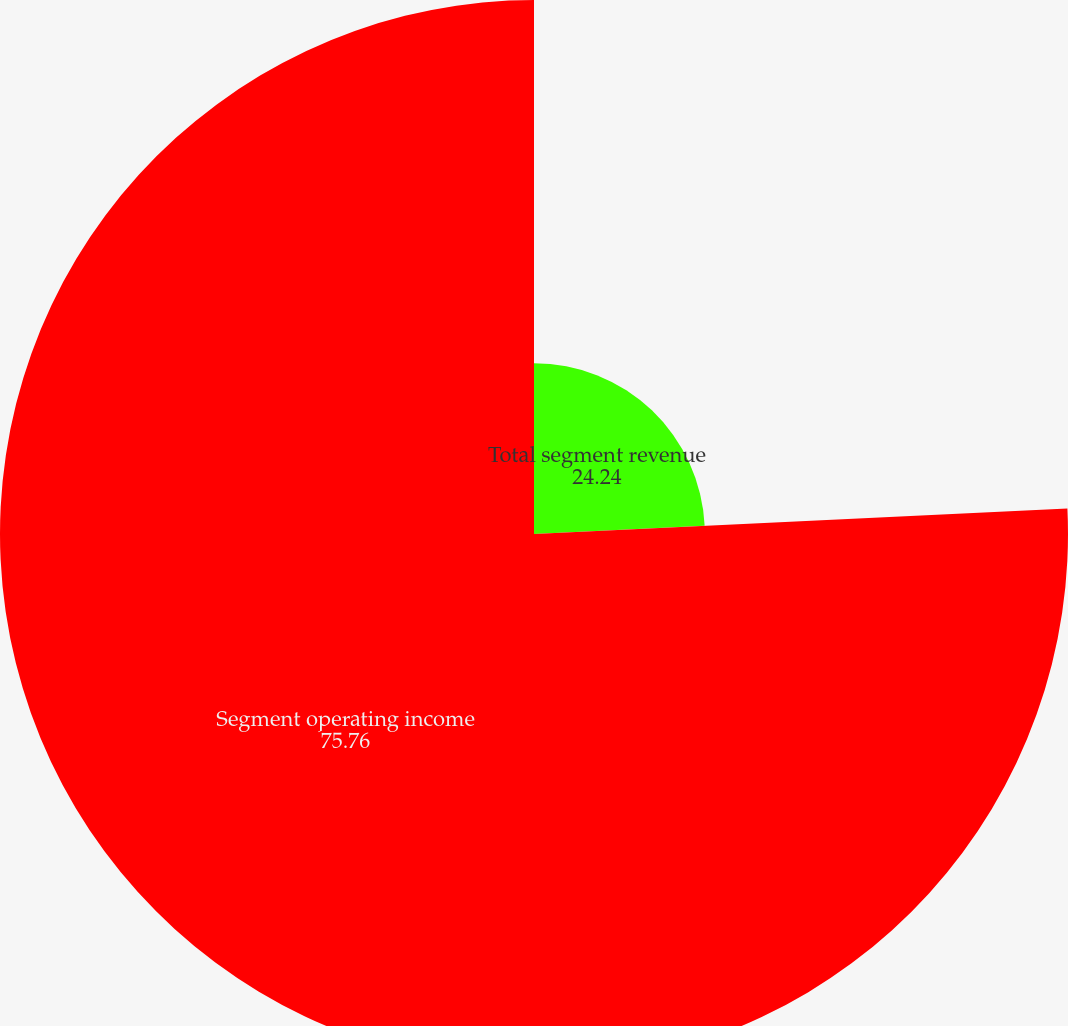Convert chart to OTSL. <chart><loc_0><loc_0><loc_500><loc_500><pie_chart><fcel>Total segment revenue<fcel>Segment operating income<nl><fcel>24.24%<fcel>75.76%<nl></chart> 